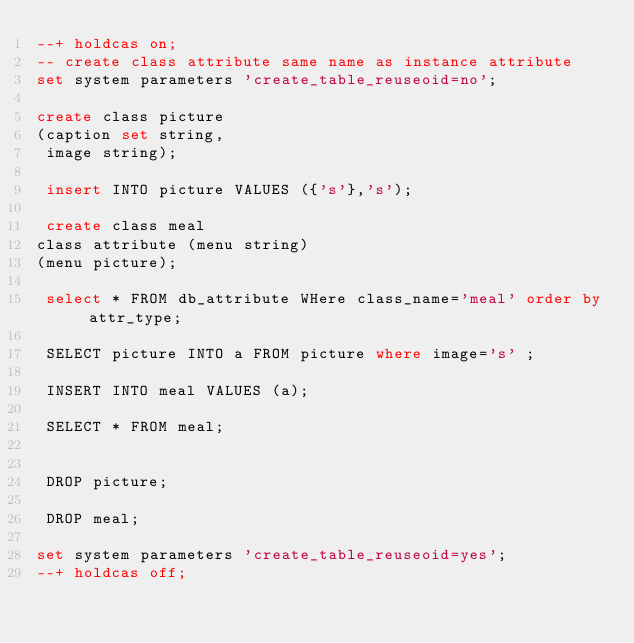<code> <loc_0><loc_0><loc_500><loc_500><_SQL_>--+ holdcas on;
-- create class attribute same name as instance attribute
set system parameters 'create_table_reuseoid=no';

create class picture
(caption set string,
 image string);
 
 insert INTO picture VALUES ({'s'},'s');
 
 create class meal
class attribute (menu string)
(menu picture);
 
 select * FROM db_attribute WHere class_name='meal' order by attr_type;
 
 SELECT picture INTO a FROM picture where image='s' ;
 
 INSERT INTO meal VALUES (a);
 
 SELECT * FROM meal;
 
 
 DROP picture;
 
 DROP meal;

set system parameters 'create_table_reuseoid=yes';
--+ holdcas off;
</code> 